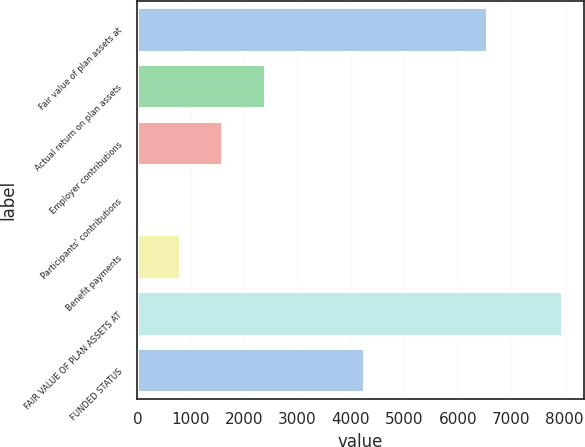Convert chart to OTSL. <chart><loc_0><loc_0><loc_500><loc_500><bar_chart><fcel>Fair value of plan assets at<fcel>Actual return on plan assets<fcel>Employer contributions<fcel>Participants' contributions<fcel>Benefit payments<fcel>FAIR VALUE OF PLAN ASSETS AT<fcel>FUNDED STATUS<nl><fcel>6562<fcel>2403.3<fcel>1609.2<fcel>21<fcel>815.1<fcel>7962<fcel>4267<nl></chart> 